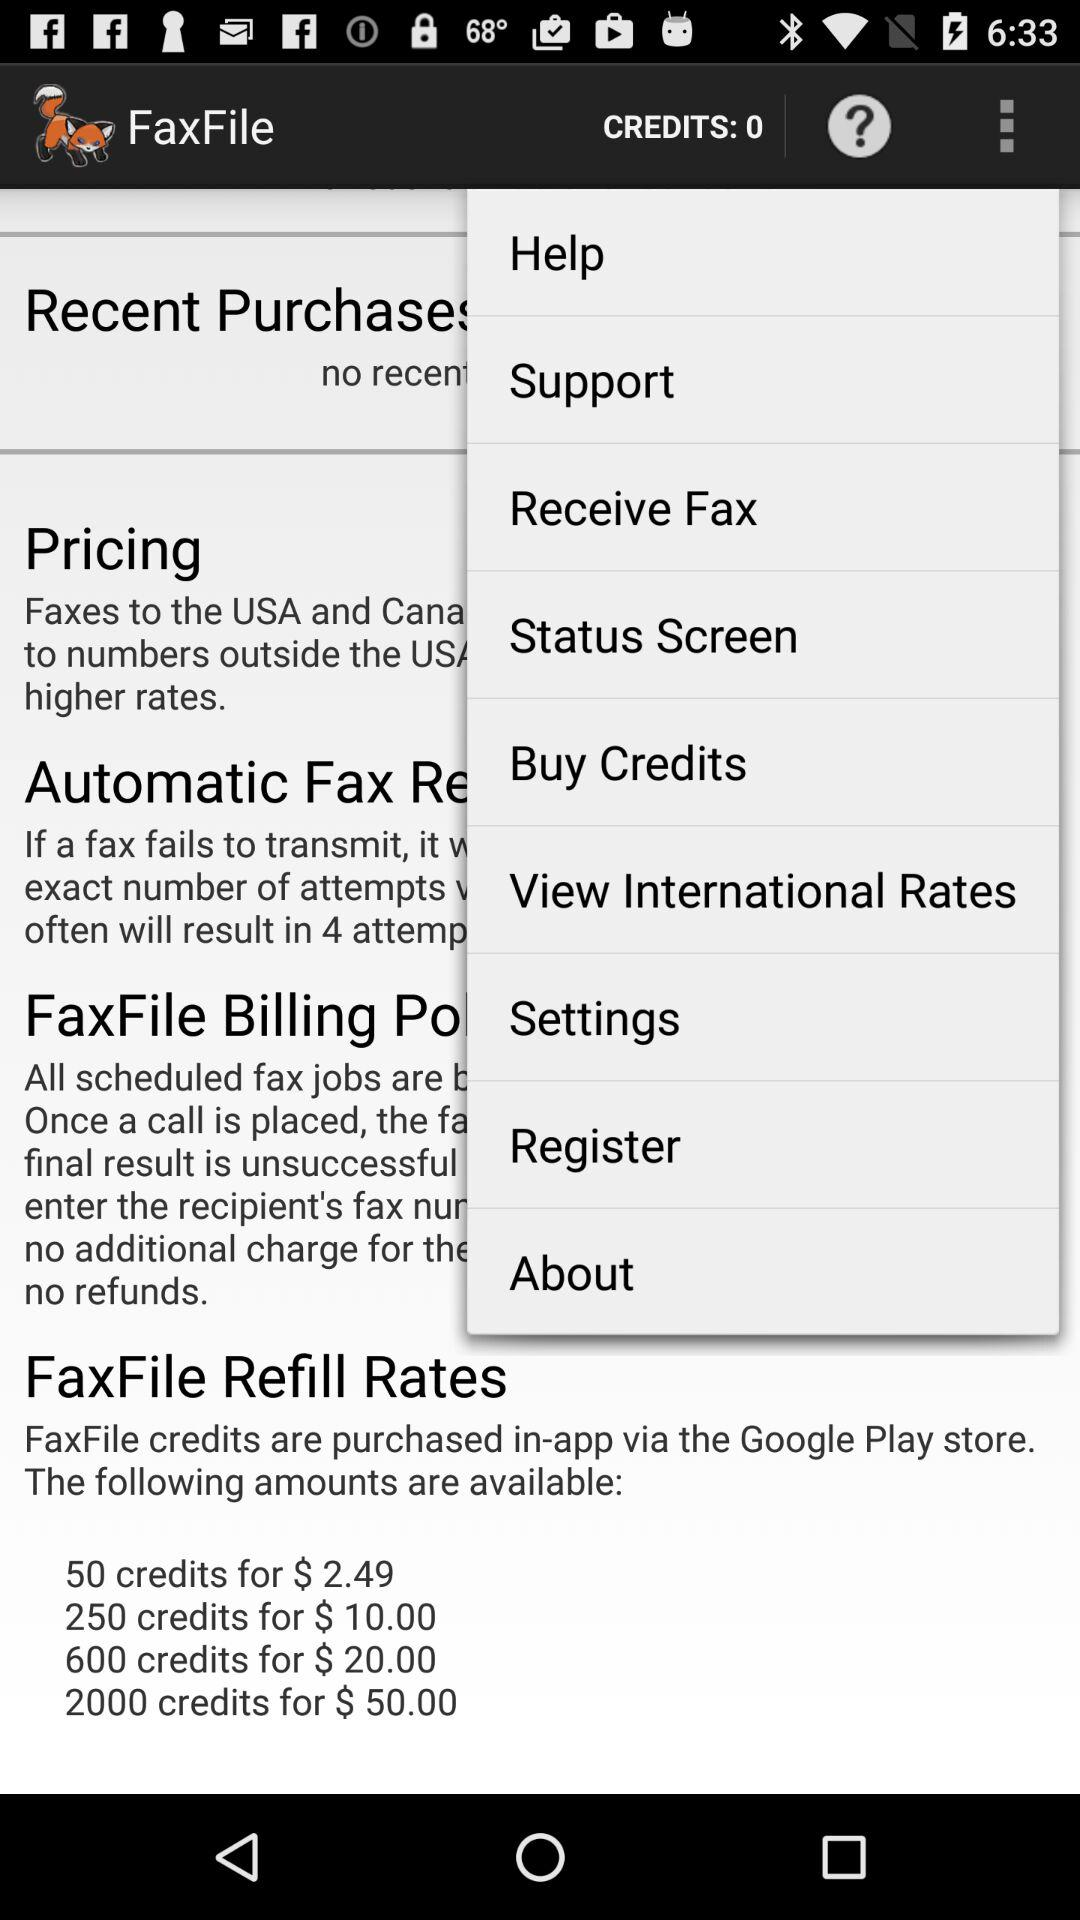How many credits are available in the smallest package?
Answer the question using a single word or phrase. 50 